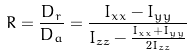<formula> <loc_0><loc_0><loc_500><loc_500>R = \frac { D _ { r } } { D _ { a } } = \frac { I _ { x x } - I _ { y y } } { I _ { z z } - \frac { I _ { x x } + I _ { y y } } { 2 I _ { z z } } }</formula> 